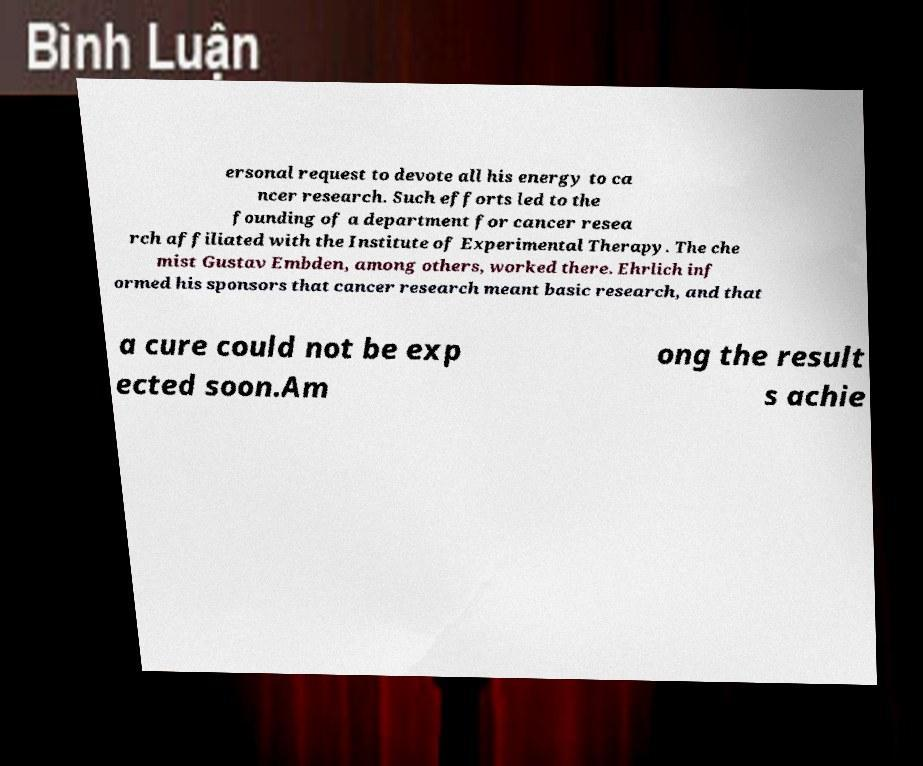I need the written content from this picture converted into text. Can you do that? ersonal request to devote all his energy to ca ncer research. Such efforts led to the founding of a department for cancer resea rch affiliated with the Institute of Experimental Therapy. The che mist Gustav Embden, among others, worked there. Ehrlich inf ormed his sponsors that cancer research meant basic research, and that a cure could not be exp ected soon.Am ong the result s achie 